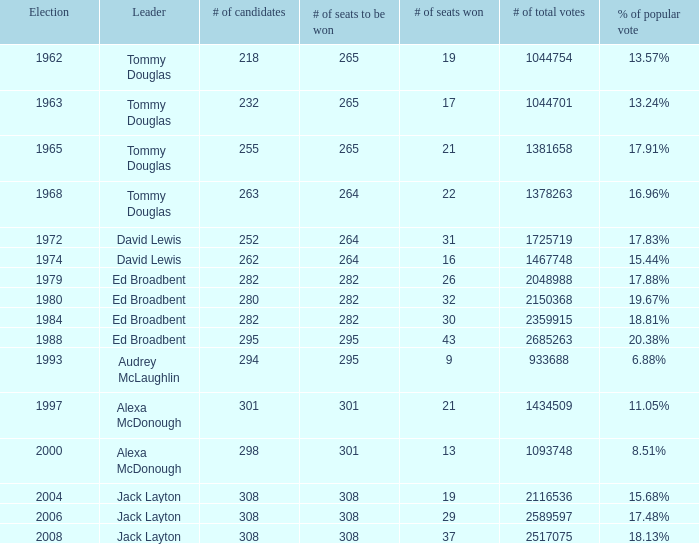Name the number of leaders for % of popular vote being 11.05% 1.0. 